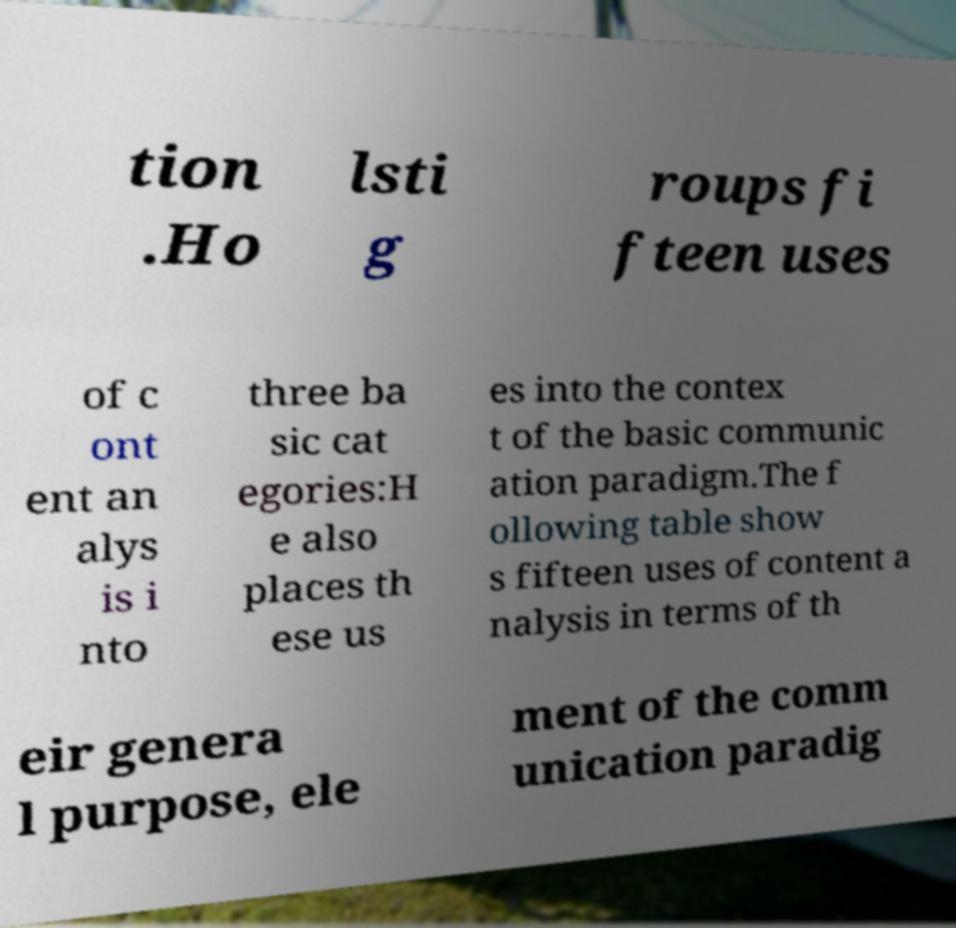What messages or text are displayed in this image? I need them in a readable, typed format. tion .Ho lsti g roups fi fteen uses of c ont ent an alys is i nto three ba sic cat egories:H e also places th ese us es into the contex t of the basic communic ation paradigm.The f ollowing table show s fifteen uses of content a nalysis in terms of th eir genera l purpose, ele ment of the comm unication paradig 